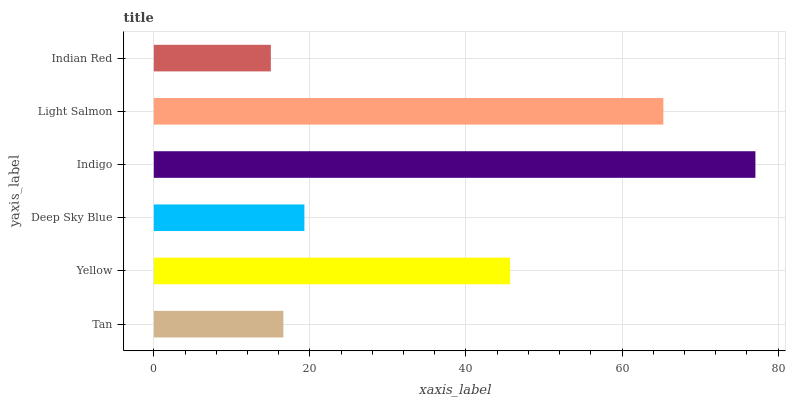Is Indian Red the minimum?
Answer yes or no. Yes. Is Indigo the maximum?
Answer yes or no. Yes. Is Yellow the minimum?
Answer yes or no. No. Is Yellow the maximum?
Answer yes or no. No. Is Yellow greater than Tan?
Answer yes or no. Yes. Is Tan less than Yellow?
Answer yes or no. Yes. Is Tan greater than Yellow?
Answer yes or no. No. Is Yellow less than Tan?
Answer yes or no. No. Is Yellow the high median?
Answer yes or no. Yes. Is Deep Sky Blue the low median?
Answer yes or no. Yes. Is Indian Red the high median?
Answer yes or no. No. Is Indigo the low median?
Answer yes or no. No. 